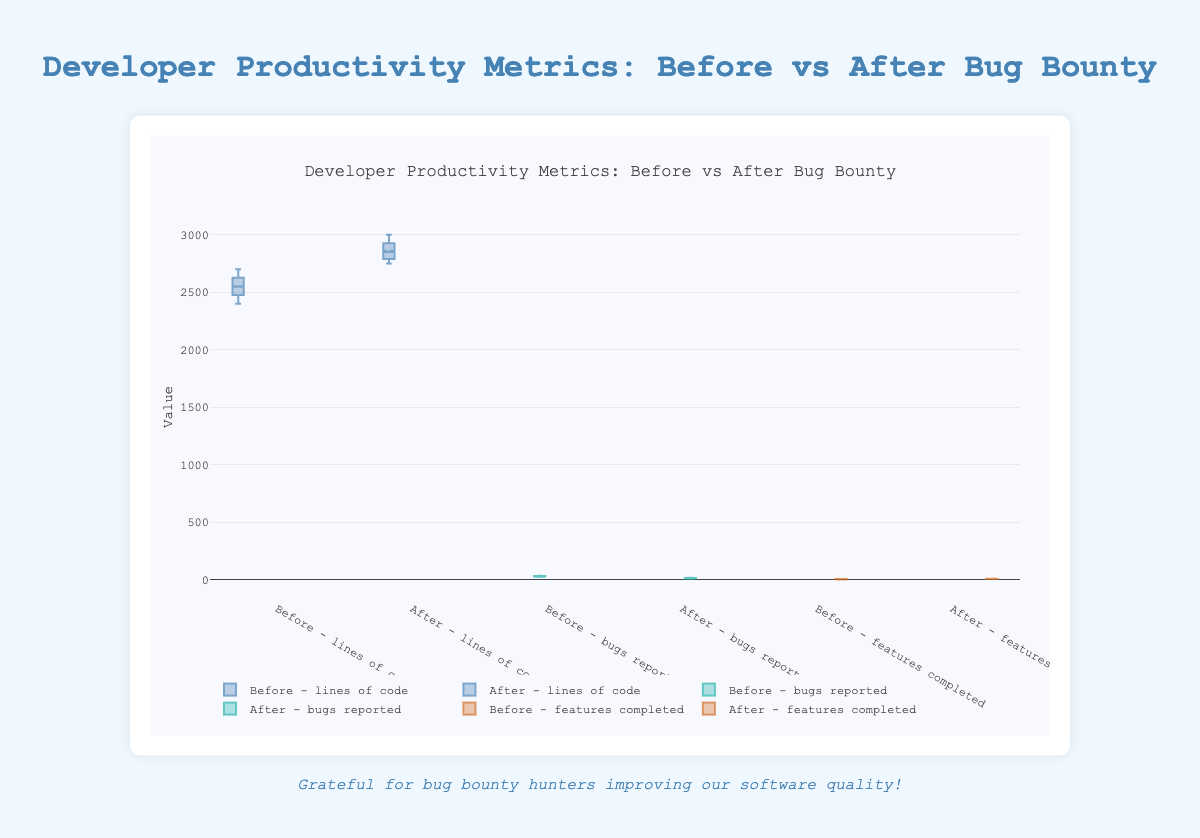what is the title of the figure? The title is usually located at the top of the figure. The title here reads "Developer Productivity Metrics: Before vs After Bug Bounty"
Answer: Developer Productivity Metrics: Before vs After Bug Bounty What does the y-axis represent? The y-axis shows the values of the metrics being measured which include "lines_of_code," "bugs_reported," and "features_completed". This is evident from the y-axis label "Value" and the data labels in the legend.
Answer: Value How many box plots are there for each metric? There are two box plots for each metric, one for before implementing the bug bounty program and one for after.
Answer: 2 What are the colors used in the box plots? The colors used in the box plots are shades of blue, green, and brown as indicated by the unique colors associated with each metric in the traces.
Answer: blue, green, brown What metric shows the clearest improvement after implementing the bug bounty program in terms of reduction? The "bugs_reported" metric shows a clear improvement due to a noticeable reduction in the values of the box plot after implementation.
Answer: bugs_reported Is there an increase in lines of code written after implementing the bug bounty program? By observing the box plots for "lines_of_code," there is an increase in the median and general range of lines of code written after implementing the bug bounty program.
Answer: Yes How does the median number of features completed compare between before and after the bug bounty program implementation? The median number of features completed after the bug bounty implementation is higher than before, as indicated by the higher central line in the box plot for "features_completed."
Answer: Higher Which metric has the largest drop in variability after implementing the bug bounty program? The "bugs_reported" metric shows the largest drop in variability; the box plot has a smaller interquartile range (IQR) and fewer outliers after the bug bounty.
Answer: bugs_reported For the "features_completed" metric, what is the difference in the range of the data before and after the bug bounty implementation? Before the bug bounty, the range is from 4 to 6. After the bug bounty, the range is from 7 to 9. The difference in range is calculated as (9-7) - (6-4) = 2-2 = 0.
Answer: 0 